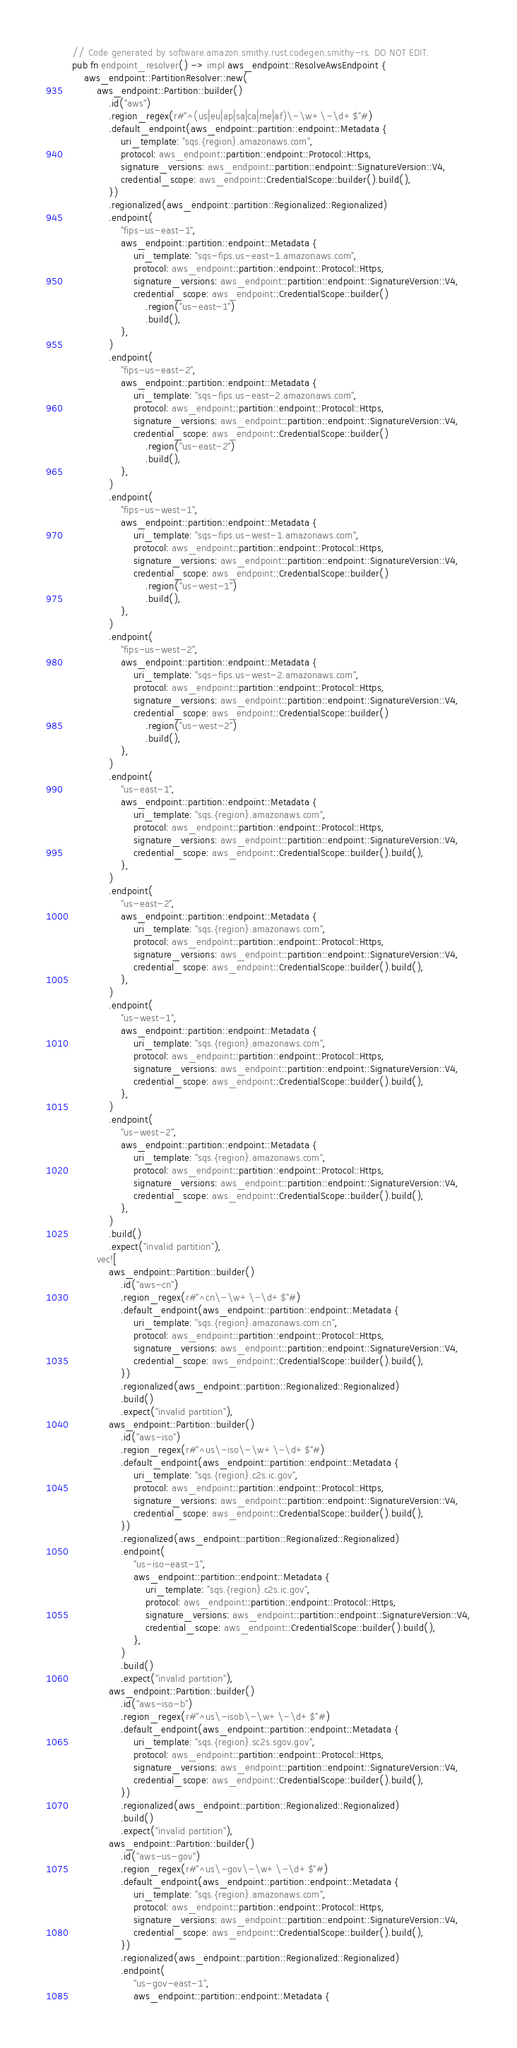<code> <loc_0><loc_0><loc_500><loc_500><_Rust_>// Code generated by software.amazon.smithy.rust.codegen.smithy-rs. DO NOT EDIT.
pub fn endpoint_resolver() -> impl aws_endpoint::ResolveAwsEndpoint {
    aws_endpoint::PartitionResolver::new(
        aws_endpoint::Partition::builder()
            .id("aws")
            .region_regex(r#"^(us|eu|ap|sa|ca|me|af)\-\w+\-\d+$"#)
            .default_endpoint(aws_endpoint::partition::endpoint::Metadata {
                uri_template: "sqs.{region}.amazonaws.com",
                protocol: aws_endpoint::partition::endpoint::Protocol::Https,
                signature_versions: aws_endpoint::partition::endpoint::SignatureVersion::V4,
                credential_scope: aws_endpoint::CredentialScope::builder().build(),
            })
            .regionalized(aws_endpoint::partition::Regionalized::Regionalized)
            .endpoint(
                "fips-us-east-1",
                aws_endpoint::partition::endpoint::Metadata {
                    uri_template: "sqs-fips.us-east-1.amazonaws.com",
                    protocol: aws_endpoint::partition::endpoint::Protocol::Https,
                    signature_versions: aws_endpoint::partition::endpoint::SignatureVersion::V4,
                    credential_scope: aws_endpoint::CredentialScope::builder()
                        .region("us-east-1")
                        .build(),
                },
            )
            .endpoint(
                "fips-us-east-2",
                aws_endpoint::partition::endpoint::Metadata {
                    uri_template: "sqs-fips.us-east-2.amazonaws.com",
                    protocol: aws_endpoint::partition::endpoint::Protocol::Https,
                    signature_versions: aws_endpoint::partition::endpoint::SignatureVersion::V4,
                    credential_scope: aws_endpoint::CredentialScope::builder()
                        .region("us-east-2")
                        .build(),
                },
            )
            .endpoint(
                "fips-us-west-1",
                aws_endpoint::partition::endpoint::Metadata {
                    uri_template: "sqs-fips.us-west-1.amazonaws.com",
                    protocol: aws_endpoint::partition::endpoint::Protocol::Https,
                    signature_versions: aws_endpoint::partition::endpoint::SignatureVersion::V4,
                    credential_scope: aws_endpoint::CredentialScope::builder()
                        .region("us-west-1")
                        .build(),
                },
            )
            .endpoint(
                "fips-us-west-2",
                aws_endpoint::partition::endpoint::Metadata {
                    uri_template: "sqs-fips.us-west-2.amazonaws.com",
                    protocol: aws_endpoint::partition::endpoint::Protocol::Https,
                    signature_versions: aws_endpoint::partition::endpoint::SignatureVersion::V4,
                    credential_scope: aws_endpoint::CredentialScope::builder()
                        .region("us-west-2")
                        .build(),
                },
            )
            .endpoint(
                "us-east-1",
                aws_endpoint::partition::endpoint::Metadata {
                    uri_template: "sqs.{region}.amazonaws.com",
                    protocol: aws_endpoint::partition::endpoint::Protocol::Https,
                    signature_versions: aws_endpoint::partition::endpoint::SignatureVersion::V4,
                    credential_scope: aws_endpoint::CredentialScope::builder().build(),
                },
            )
            .endpoint(
                "us-east-2",
                aws_endpoint::partition::endpoint::Metadata {
                    uri_template: "sqs.{region}.amazonaws.com",
                    protocol: aws_endpoint::partition::endpoint::Protocol::Https,
                    signature_versions: aws_endpoint::partition::endpoint::SignatureVersion::V4,
                    credential_scope: aws_endpoint::CredentialScope::builder().build(),
                },
            )
            .endpoint(
                "us-west-1",
                aws_endpoint::partition::endpoint::Metadata {
                    uri_template: "sqs.{region}.amazonaws.com",
                    protocol: aws_endpoint::partition::endpoint::Protocol::Https,
                    signature_versions: aws_endpoint::partition::endpoint::SignatureVersion::V4,
                    credential_scope: aws_endpoint::CredentialScope::builder().build(),
                },
            )
            .endpoint(
                "us-west-2",
                aws_endpoint::partition::endpoint::Metadata {
                    uri_template: "sqs.{region}.amazonaws.com",
                    protocol: aws_endpoint::partition::endpoint::Protocol::Https,
                    signature_versions: aws_endpoint::partition::endpoint::SignatureVersion::V4,
                    credential_scope: aws_endpoint::CredentialScope::builder().build(),
                },
            )
            .build()
            .expect("invalid partition"),
        vec![
            aws_endpoint::Partition::builder()
                .id("aws-cn")
                .region_regex(r#"^cn\-\w+\-\d+$"#)
                .default_endpoint(aws_endpoint::partition::endpoint::Metadata {
                    uri_template: "sqs.{region}.amazonaws.com.cn",
                    protocol: aws_endpoint::partition::endpoint::Protocol::Https,
                    signature_versions: aws_endpoint::partition::endpoint::SignatureVersion::V4,
                    credential_scope: aws_endpoint::CredentialScope::builder().build(),
                })
                .regionalized(aws_endpoint::partition::Regionalized::Regionalized)
                .build()
                .expect("invalid partition"),
            aws_endpoint::Partition::builder()
                .id("aws-iso")
                .region_regex(r#"^us\-iso\-\w+\-\d+$"#)
                .default_endpoint(aws_endpoint::partition::endpoint::Metadata {
                    uri_template: "sqs.{region}.c2s.ic.gov",
                    protocol: aws_endpoint::partition::endpoint::Protocol::Https,
                    signature_versions: aws_endpoint::partition::endpoint::SignatureVersion::V4,
                    credential_scope: aws_endpoint::CredentialScope::builder().build(),
                })
                .regionalized(aws_endpoint::partition::Regionalized::Regionalized)
                .endpoint(
                    "us-iso-east-1",
                    aws_endpoint::partition::endpoint::Metadata {
                        uri_template: "sqs.{region}.c2s.ic.gov",
                        protocol: aws_endpoint::partition::endpoint::Protocol::Https,
                        signature_versions: aws_endpoint::partition::endpoint::SignatureVersion::V4,
                        credential_scope: aws_endpoint::CredentialScope::builder().build(),
                    },
                )
                .build()
                .expect("invalid partition"),
            aws_endpoint::Partition::builder()
                .id("aws-iso-b")
                .region_regex(r#"^us\-isob\-\w+\-\d+$"#)
                .default_endpoint(aws_endpoint::partition::endpoint::Metadata {
                    uri_template: "sqs.{region}.sc2s.sgov.gov",
                    protocol: aws_endpoint::partition::endpoint::Protocol::Https,
                    signature_versions: aws_endpoint::partition::endpoint::SignatureVersion::V4,
                    credential_scope: aws_endpoint::CredentialScope::builder().build(),
                })
                .regionalized(aws_endpoint::partition::Regionalized::Regionalized)
                .build()
                .expect("invalid partition"),
            aws_endpoint::Partition::builder()
                .id("aws-us-gov")
                .region_regex(r#"^us\-gov\-\w+\-\d+$"#)
                .default_endpoint(aws_endpoint::partition::endpoint::Metadata {
                    uri_template: "sqs.{region}.amazonaws.com",
                    protocol: aws_endpoint::partition::endpoint::Protocol::Https,
                    signature_versions: aws_endpoint::partition::endpoint::SignatureVersion::V4,
                    credential_scope: aws_endpoint::CredentialScope::builder().build(),
                })
                .regionalized(aws_endpoint::partition::Regionalized::Regionalized)
                .endpoint(
                    "us-gov-east-1",
                    aws_endpoint::partition::endpoint::Metadata {</code> 